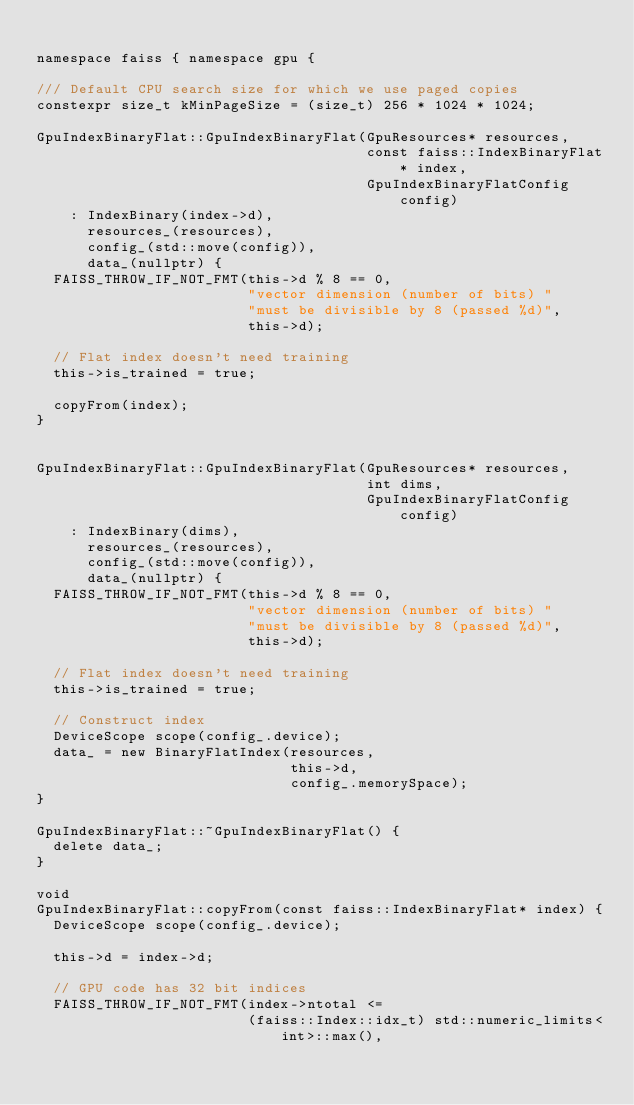<code> <loc_0><loc_0><loc_500><loc_500><_Cuda_>
namespace faiss { namespace gpu {

/// Default CPU search size for which we use paged copies
constexpr size_t kMinPageSize = (size_t) 256 * 1024 * 1024;

GpuIndexBinaryFlat::GpuIndexBinaryFlat(GpuResources* resources,
                                       const faiss::IndexBinaryFlat* index,
                                       GpuIndexBinaryFlatConfig config)
    : IndexBinary(index->d),
      resources_(resources),
      config_(std::move(config)),
      data_(nullptr) {
  FAISS_THROW_IF_NOT_FMT(this->d % 8 == 0,
                         "vector dimension (number of bits) "
                         "must be divisible by 8 (passed %d)",
                         this->d);

  // Flat index doesn't need training
  this->is_trained = true;

  copyFrom(index);
}


GpuIndexBinaryFlat::GpuIndexBinaryFlat(GpuResources* resources,
                                       int dims,
                                       GpuIndexBinaryFlatConfig config)
    : IndexBinary(dims),
      resources_(resources),
      config_(std::move(config)),
      data_(nullptr) {
  FAISS_THROW_IF_NOT_FMT(this->d % 8 == 0,
                         "vector dimension (number of bits) "
                         "must be divisible by 8 (passed %d)",
                         this->d);

  // Flat index doesn't need training
  this->is_trained = true;

  // Construct index
  DeviceScope scope(config_.device);
  data_ = new BinaryFlatIndex(resources,
                              this->d,
                              config_.memorySpace);
}

GpuIndexBinaryFlat::~GpuIndexBinaryFlat() {
  delete data_;
}

void
GpuIndexBinaryFlat::copyFrom(const faiss::IndexBinaryFlat* index) {
  DeviceScope scope(config_.device);

  this->d = index->d;

  // GPU code has 32 bit indices
  FAISS_THROW_IF_NOT_FMT(index->ntotal <=
                         (faiss::Index::idx_t) std::numeric_limits<int>::max(),</code> 